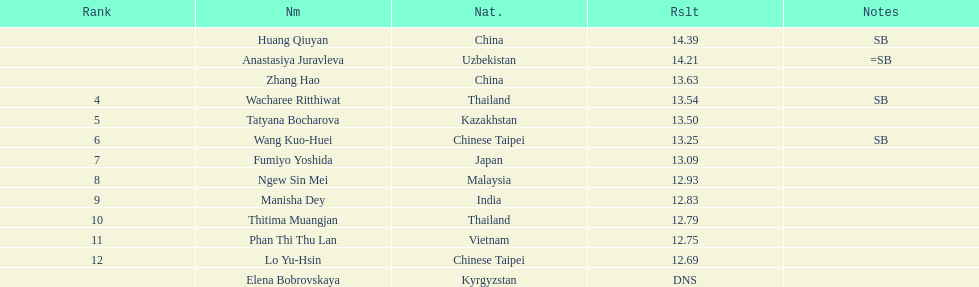During the event, which country had the largest number of competitors ranking in the top three? China. 